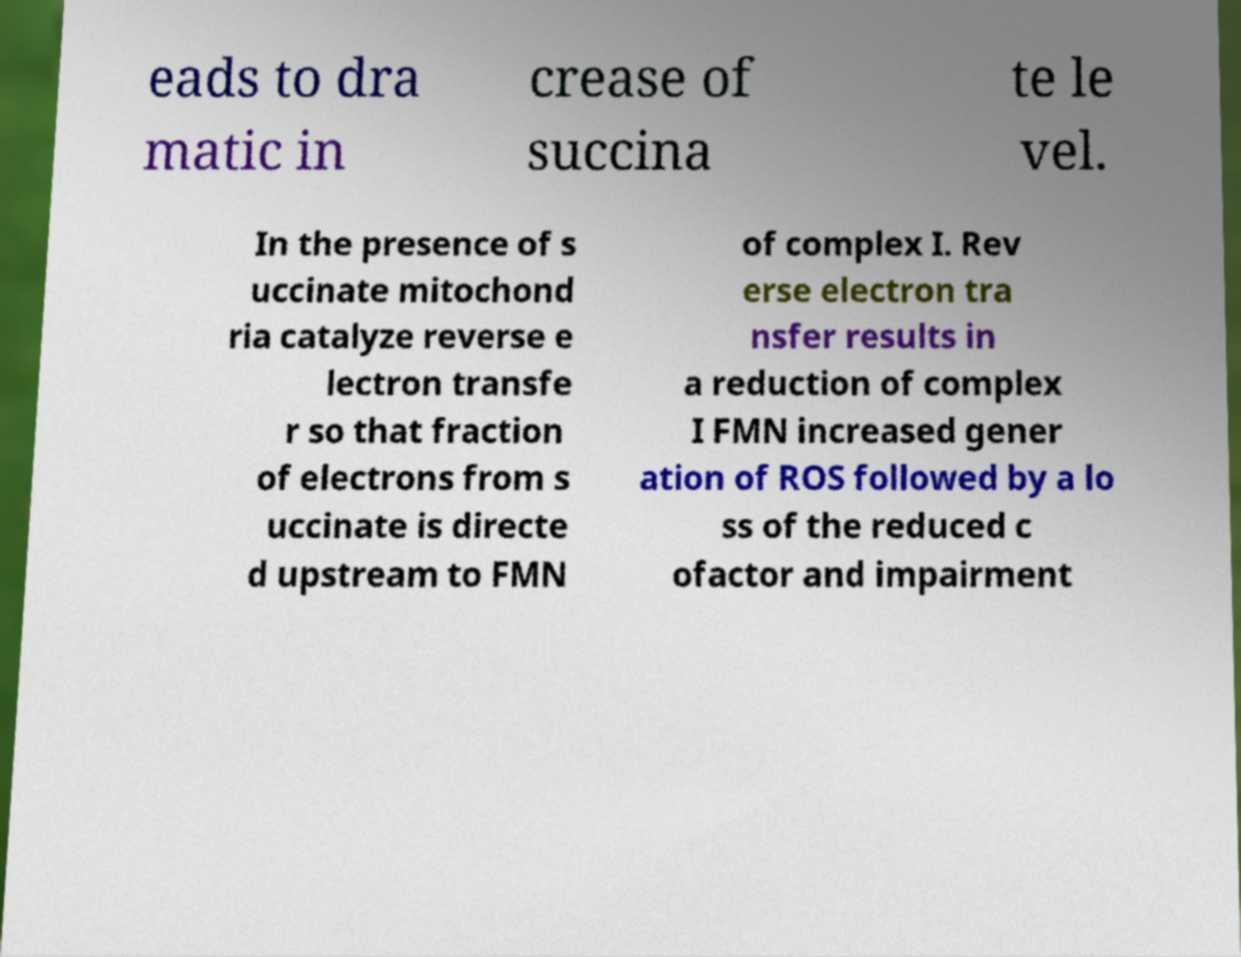Please read and relay the text visible in this image. What does it say? eads to dra matic in crease of succina te le vel. In the presence of s uccinate mitochond ria catalyze reverse e lectron transfe r so that fraction of electrons from s uccinate is directe d upstream to FMN of complex I. Rev erse electron tra nsfer results in a reduction of complex I FMN increased gener ation of ROS followed by a lo ss of the reduced c ofactor and impairment 